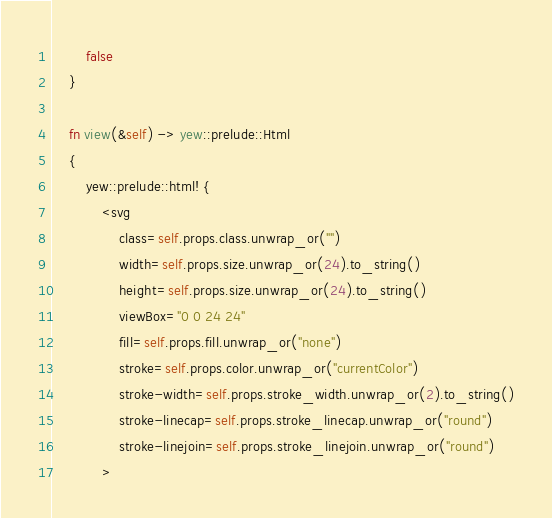<code> <loc_0><loc_0><loc_500><loc_500><_Rust_>        false
    }

    fn view(&self) -> yew::prelude::Html
    {
        yew::prelude::html! {
            <svg
                class=self.props.class.unwrap_or("")
                width=self.props.size.unwrap_or(24).to_string()
                height=self.props.size.unwrap_or(24).to_string()
                viewBox="0 0 24 24"
                fill=self.props.fill.unwrap_or("none")
                stroke=self.props.color.unwrap_or("currentColor")
                stroke-width=self.props.stroke_width.unwrap_or(2).to_string()
                stroke-linecap=self.props.stroke_linecap.unwrap_or("round")
                stroke-linejoin=self.props.stroke_linejoin.unwrap_or("round")
            ></code> 